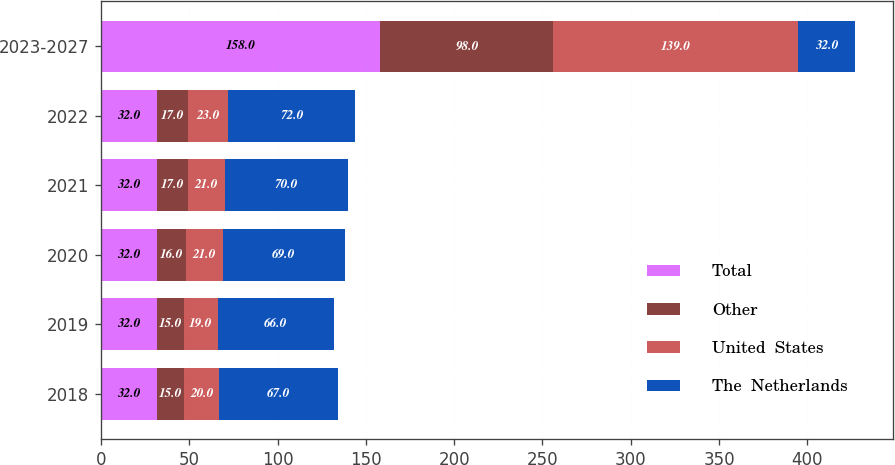Convert chart. <chart><loc_0><loc_0><loc_500><loc_500><stacked_bar_chart><ecel><fcel>2018<fcel>2019<fcel>2020<fcel>2021<fcel>2022<fcel>2023-2027<nl><fcel>Total<fcel>32<fcel>32<fcel>32<fcel>32<fcel>32<fcel>158<nl><fcel>Other<fcel>15<fcel>15<fcel>16<fcel>17<fcel>17<fcel>98<nl><fcel>United  States<fcel>20<fcel>19<fcel>21<fcel>21<fcel>23<fcel>139<nl><fcel>The  Netherlands<fcel>67<fcel>66<fcel>69<fcel>70<fcel>72<fcel>32<nl></chart> 